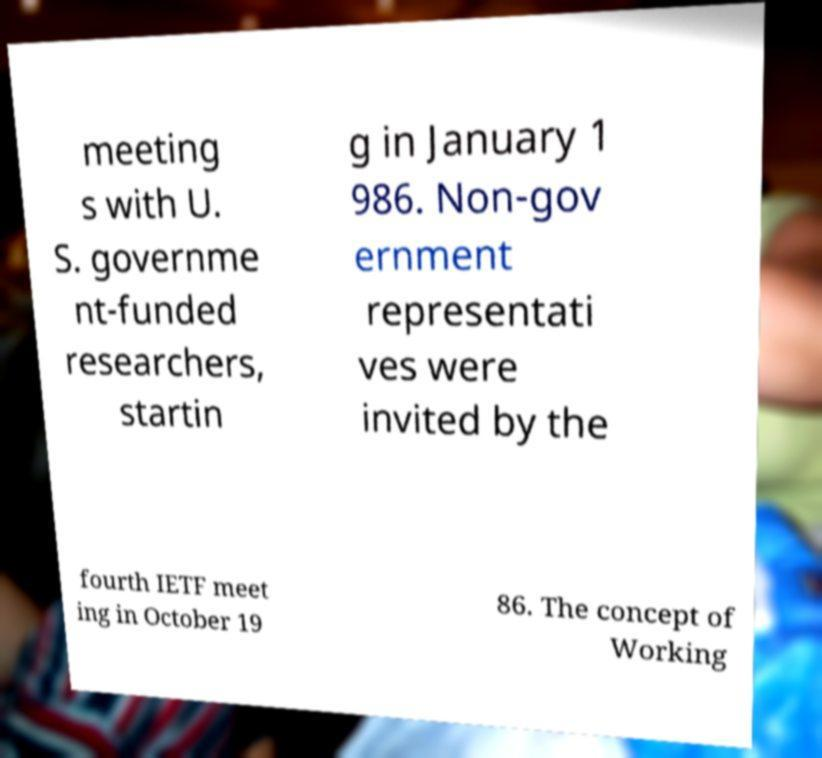Please identify and transcribe the text found in this image. meeting s with U. S. governme nt-funded researchers, startin g in January 1 986. Non-gov ernment representati ves were invited by the fourth IETF meet ing in October 19 86. The concept of Working 